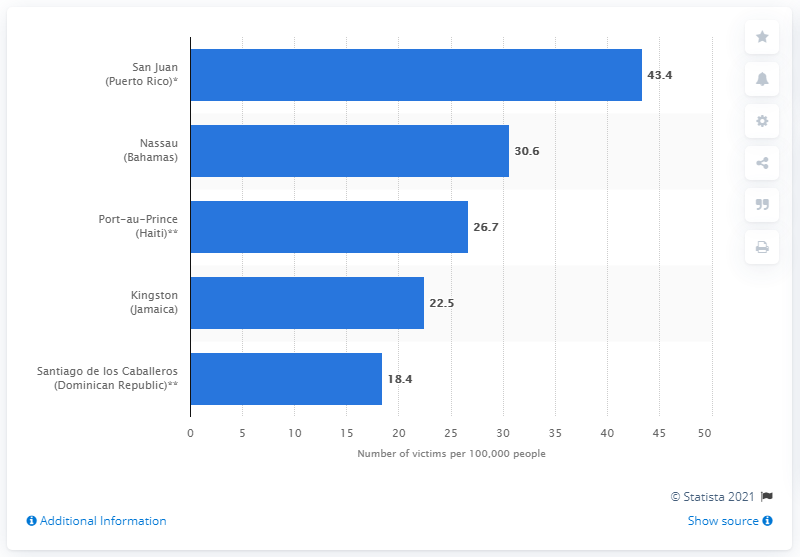Outline some significant characteristics in this image. The homicide rate in Nassau was 30.6... 